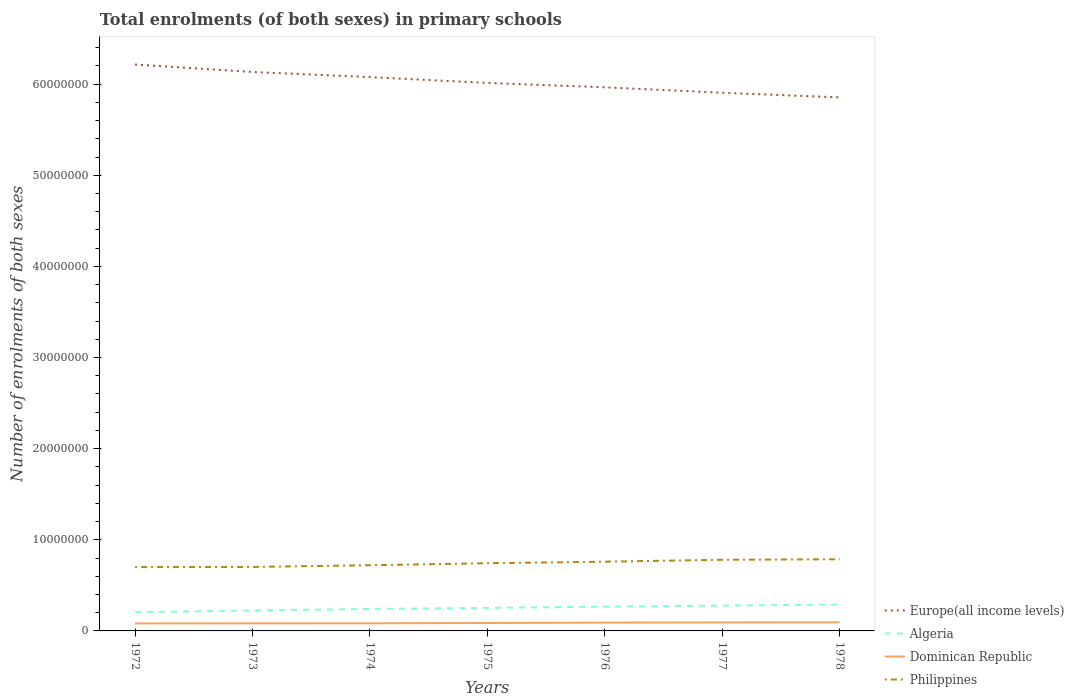Does the line corresponding to Dominican Republic intersect with the line corresponding to Philippines?
Your response must be concise. No. Across all years, what is the maximum number of enrolments in primary schools in Dominican Republic?
Give a very brief answer. 8.24e+05. In which year was the number of enrolments in primary schools in Algeria maximum?
Your answer should be compact. 1972. What is the total number of enrolments in primary schools in Dominican Republic in the graph?
Give a very brief answer. -9.78e+04. What is the difference between the highest and the second highest number of enrolments in primary schools in Algeria?
Make the answer very short. 8.37e+05. Is the number of enrolments in primary schools in Philippines strictly greater than the number of enrolments in primary schools in Dominican Republic over the years?
Make the answer very short. No. How many lines are there?
Provide a succinct answer. 4. How many years are there in the graph?
Offer a terse response. 7. What is the difference between two consecutive major ticks on the Y-axis?
Offer a very short reply. 1.00e+07. Does the graph contain grids?
Your answer should be very brief. No. How many legend labels are there?
Provide a short and direct response. 4. What is the title of the graph?
Your answer should be compact. Total enrolments (of both sexes) in primary schools. What is the label or title of the Y-axis?
Make the answer very short. Number of enrolments of both sexes. What is the Number of enrolments of both sexes of Europe(all income levels) in 1972?
Your answer should be very brief. 6.22e+07. What is the Number of enrolments of both sexes in Algeria in 1972?
Provide a succinct answer. 2.06e+06. What is the Number of enrolments of both sexes of Dominican Republic in 1972?
Make the answer very short. 8.24e+05. What is the Number of enrolments of both sexes of Philippines in 1972?
Ensure brevity in your answer.  7.00e+06. What is the Number of enrolments of both sexes in Europe(all income levels) in 1973?
Provide a succinct answer. 6.13e+07. What is the Number of enrolments of both sexes of Algeria in 1973?
Your answer should be compact. 2.24e+06. What is the Number of enrolments of both sexes in Dominican Republic in 1973?
Make the answer very short. 8.33e+05. What is the Number of enrolments of both sexes in Philippines in 1973?
Keep it short and to the point. 7.02e+06. What is the Number of enrolments of both sexes in Europe(all income levels) in 1974?
Provide a short and direct response. 6.08e+07. What is the Number of enrolments of both sexes in Algeria in 1974?
Provide a succinct answer. 2.41e+06. What is the Number of enrolments of both sexes of Dominican Republic in 1974?
Make the answer very short. 8.37e+05. What is the Number of enrolments of both sexes in Philippines in 1974?
Keep it short and to the point. 7.21e+06. What is the Number of enrolments of both sexes in Europe(all income levels) in 1975?
Your response must be concise. 6.01e+07. What is the Number of enrolments of both sexes in Algeria in 1975?
Provide a succinct answer. 2.53e+06. What is the Number of enrolments of both sexes in Dominican Republic in 1975?
Your response must be concise. 8.68e+05. What is the Number of enrolments of both sexes in Philippines in 1975?
Provide a short and direct response. 7.43e+06. What is the Number of enrolments of both sexes of Europe(all income levels) in 1976?
Your response must be concise. 5.97e+07. What is the Number of enrolments of both sexes of Algeria in 1976?
Your answer should be compact. 2.66e+06. What is the Number of enrolments of both sexes of Dominican Republic in 1976?
Make the answer very short. 9.11e+05. What is the Number of enrolments of both sexes of Philippines in 1976?
Offer a terse response. 7.60e+06. What is the Number of enrolments of both sexes in Europe(all income levels) in 1977?
Ensure brevity in your answer.  5.91e+07. What is the Number of enrolments of both sexes of Algeria in 1977?
Provide a short and direct response. 2.79e+06. What is the Number of enrolments of both sexes in Dominican Republic in 1977?
Keep it short and to the point. 9.35e+05. What is the Number of enrolments of both sexes in Philippines in 1977?
Offer a terse response. 7.81e+06. What is the Number of enrolments of both sexes in Europe(all income levels) in 1978?
Your answer should be very brief. 5.86e+07. What is the Number of enrolments of both sexes of Algeria in 1978?
Offer a terse response. 2.89e+06. What is the Number of enrolments of both sexes in Dominican Republic in 1978?
Make the answer very short. 9.47e+05. What is the Number of enrolments of both sexes of Philippines in 1978?
Offer a terse response. 7.86e+06. Across all years, what is the maximum Number of enrolments of both sexes in Europe(all income levels)?
Ensure brevity in your answer.  6.22e+07. Across all years, what is the maximum Number of enrolments of both sexes of Algeria?
Your answer should be very brief. 2.89e+06. Across all years, what is the maximum Number of enrolments of both sexes in Dominican Republic?
Offer a terse response. 9.47e+05. Across all years, what is the maximum Number of enrolments of both sexes in Philippines?
Provide a short and direct response. 7.86e+06. Across all years, what is the minimum Number of enrolments of both sexes of Europe(all income levels)?
Offer a very short reply. 5.86e+07. Across all years, what is the minimum Number of enrolments of both sexes of Algeria?
Make the answer very short. 2.06e+06. Across all years, what is the minimum Number of enrolments of both sexes in Dominican Republic?
Make the answer very short. 8.24e+05. Across all years, what is the minimum Number of enrolments of both sexes of Philippines?
Keep it short and to the point. 7.00e+06. What is the total Number of enrolments of both sexes in Europe(all income levels) in the graph?
Offer a very short reply. 4.22e+08. What is the total Number of enrolments of both sexes of Algeria in the graph?
Provide a succinct answer. 1.76e+07. What is the total Number of enrolments of both sexes in Dominican Republic in the graph?
Keep it short and to the point. 6.15e+06. What is the total Number of enrolments of both sexes of Philippines in the graph?
Make the answer very short. 5.19e+07. What is the difference between the Number of enrolments of both sexes of Europe(all income levels) in 1972 and that in 1973?
Keep it short and to the point. 8.20e+05. What is the difference between the Number of enrolments of both sexes of Algeria in 1972 and that in 1973?
Give a very brief answer. -1.88e+05. What is the difference between the Number of enrolments of both sexes in Dominican Republic in 1972 and that in 1973?
Make the answer very short. -9886. What is the difference between the Number of enrolments of both sexes of Philippines in 1972 and that in 1973?
Your answer should be very brief. -2.07e+04. What is the difference between the Number of enrolments of both sexes of Europe(all income levels) in 1972 and that in 1974?
Give a very brief answer. 1.38e+06. What is the difference between the Number of enrolments of both sexes of Algeria in 1972 and that in 1974?
Give a very brief answer. -3.52e+05. What is the difference between the Number of enrolments of both sexes of Dominican Republic in 1972 and that in 1974?
Provide a short and direct response. -1.34e+04. What is the difference between the Number of enrolments of both sexes in Philippines in 1972 and that in 1974?
Provide a short and direct response. -2.07e+05. What is the difference between the Number of enrolments of both sexes in Europe(all income levels) in 1972 and that in 1975?
Your answer should be compact. 2.02e+06. What is the difference between the Number of enrolments of both sexes of Algeria in 1972 and that in 1975?
Keep it short and to the point. -4.68e+05. What is the difference between the Number of enrolments of both sexes in Dominican Republic in 1972 and that in 1975?
Your answer should be very brief. -4.40e+04. What is the difference between the Number of enrolments of both sexes of Philippines in 1972 and that in 1975?
Your response must be concise. -4.27e+05. What is the difference between the Number of enrolments of both sexes in Europe(all income levels) in 1972 and that in 1976?
Your answer should be compact. 2.50e+06. What is the difference between the Number of enrolments of both sexes in Algeria in 1972 and that in 1976?
Your answer should be compact. -6.06e+05. What is the difference between the Number of enrolments of both sexes in Dominican Republic in 1972 and that in 1976?
Offer a very short reply. -8.76e+04. What is the difference between the Number of enrolments of both sexes of Philippines in 1972 and that in 1976?
Offer a terse response. -5.95e+05. What is the difference between the Number of enrolments of both sexes of Europe(all income levels) in 1972 and that in 1977?
Your answer should be very brief. 3.10e+06. What is the difference between the Number of enrolments of both sexes of Algeria in 1972 and that in 1977?
Offer a terse response. -7.28e+05. What is the difference between the Number of enrolments of both sexes of Dominican Republic in 1972 and that in 1977?
Your answer should be compact. -1.11e+05. What is the difference between the Number of enrolments of both sexes in Philippines in 1972 and that in 1977?
Make the answer very short. -8.06e+05. What is the difference between the Number of enrolments of both sexes of Europe(all income levels) in 1972 and that in 1978?
Your answer should be compact. 3.61e+06. What is the difference between the Number of enrolments of both sexes of Algeria in 1972 and that in 1978?
Give a very brief answer. -8.37e+05. What is the difference between the Number of enrolments of both sexes of Dominican Republic in 1972 and that in 1978?
Your answer should be compact. -1.23e+05. What is the difference between the Number of enrolments of both sexes of Philippines in 1972 and that in 1978?
Offer a terse response. -8.60e+05. What is the difference between the Number of enrolments of both sexes of Europe(all income levels) in 1973 and that in 1974?
Ensure brevity in your answer.  5.63e+05. What is the difference between the Number of enrolments of both sexes in Algeria in 1973 and that in 1974?
Provide a short and direct response. -1.65e+05. What is the difference between the Number of enrolments of both sexes of Dominican Republic in 1973 and that in 1974?
Offer a terse response. -3503. What is the difference between the Number of enrolments of both sexes in Philippines in 1973 and that in 1974?
Provide a short and direct response. -1.86e+05. What is the difference between the Number of enrolments of both sexes in Europe(all income levels) in 1973 and that in 1975?
Your answer should be very brief. 1.20e+06. What is the difference between the Number of enrolments of both sexes in Algeria in 1973 and that in 1975?
Give a very brief answer. -2.81e+05. What is the difference between the Number of enrolments of both sexes of Dominican Republic in 1973 and that in 1975?
Make the answer very short. -3.42e+04. What is the difference between the Number of enrolments of both sexes of Philippines in 1973 and that in 1975?
Your answer should be very brief. -4.07e+05. What is the difference between the Number of enrolments of both sexes in Europe(all income levels) in 1973 and that in 1976?
Provide a succinct answer. 1.68e+06. What is the difference between the Number of enrolments of both sexes of Algeria in 1973 and that in 1976?
Your response must be concise. -4.18e+05. What is the difference between the Number of enrolments of both sexes of Dominican Republic in 1973 and that in 1976?
Offer a terse response. -7.77e+04. What is the difference between the Number of enrolments of both sexes of Philippines in 1973 and that in 1976?
Your answer should be very brief. -5.75e+05. What is the difference between the Number of enrolments of both sexes of Europe(all income levels) in 1973 and that in 1977?
Offer a very short reply. 2.28e+06. What is the difference between the Number of enrolments of both sexes in Algeria in 1973 and that in 1977?
Your answer should be very brief. -5.40e+05. What is the difference between the Number of enrolments of both sexes in Dominican Republic in 1973 and that in 1977?
Provide a succinct answer. -1.01e+05. What is the difference between the Number of enrolments of both sexes of Philippines in 1973 and that in 1977?
Offer a terse response. -7.85e+05. What is the difference between the Number of enrolments of both sexes in Europe(all income levels) in 1973 and that in 1978?
Your response must be concise. 2.79e+06. What is the difference between the Number of enrolments of both sexes in Algeria in 1973 and that in 1978?
Ensure brevity in your answer.  -6.49e+05. What is the difference between the Number of enrolments of both sexes of Dominican Republic in 1973 and that in 1978?
Make the answer very short. -1.13e+05. What is the difference between the Number of enrolments of both sexes in Philippines in 1973 and that in 1978?
Your answer should be compact. -8.39e+05. What is the difference between the Number of enrolments of both sexes in Europe(all income levels) in 1974 and that in 1975?
Provide a short and direct response. 6.37e+05. What is the difference between the Number of enrolments of both sexes in Algeria in 1974 and that in 1975?
Provide a succinct answer. -1.16e+05. What is the difference between the Number of enrolments of both sexes of Dominican Republic in 1974 and that in 1975?
Your response must be concise. -3.06e+04. What is the difference between the Number of enrolments of both sexes in Philippines in 1974 and that in 1975?
Ensure brevity in your answer.  -2.20e+05. What is the difference between the Number of enrolments of both sexes in Europe(all income levels) in 1974 and that in 1976?
Make the answer very short. 1.12e+06. What is the difference between the Number of enrolments of both sexes of Algeria in 1974 and that in 1976?
Make the answer very short. -2.54e+05. What is the difference between the Number of enrolments of both sexes in Dominican Republic in 1974 and that in 1976?
Provide a succinct answer. -7.42e+04. What is the difference between the Number of enrolments of both sexes of Philippines in 1974 and that in 1976?
Your answer should be compact. -3.88e+05. What is the difference between the Number of enrolments of both sexes in Europe(all income levels) in 1974 and that in 1977?
Your answer should be compact. 1.72e+06. What is the difference between the Number of enrolments of both sexes of Algeria in 1974 and that in 1977?
Provide a short and direct response. -3.76e+05. What is the difference between the Number of enrolments of both sexes in Dominican Republic in 1974 and that in 1977?
Ensure brevity in your answer.  -9.78e+04. What is the difference between the Number of enrolments of both sexes in Philippines in 1974 and that in 1977?
Make the answer very short. -5.99e+05. What is the difference between the Number of enrolments of both sexes of Europe(all income levels) in 1974 and that in 1978?
Your answer should be compact. 2.22e+06. What is the difference between the Number of enrolments of both sexes in Algeria in 1974 and that in 1978?
Your answer should be very brief. -4.85e+05. What is the difference between the Number of enrolments of both sexes in Dominican Republic in 1974 and that in 1978?
Offer a very short reply. -1.10e+05. What is the difference between the Number of enrolments of both sexes in Philippines in 1974 and that in 1978?
Offer a terse response. -6.53e+05. What is the difference between the Number of enrolments of both sexes of Europe(all income levels) in 1975 and that in 1976?
Offer a terse response. 4.81e+05. What is the difference between the Number of enrolments of both sexes in Algeria in 1975 and that in 1976?
Your response must be concise. -1.38e+05. What is the difference between the Number of enrolments of both sexes of Dominican Republic in 1975 and that in 1976?
Ensure brevity in your answer.  -4.36e+04. What is the difference between the Number of enrolments of both sexes in Philippines in 1975 and that in 1976?
Your answer should be very brief. -1.68e+05. What is the difference between the Number of enrolments of both sexes in Europe(all income levels) in 1975 and that in 1977?
Ensure brevity in your answer.  1.08e+06. What is the difference between the Number of enrolments of both sexes in Algeria in 1975 and that in 1977?
Your answer should be compact. -2.60e+05. What is the difference between the Number of enrolments of both sexes in Dominican Republic in 1975 and that in 1977?
Ensure brevity in your answer.  -6.72e+04. What is the difference between the Number of enrolments of both sexes in Philippines in 1975 and that in 1977?
Provide a short and direct response. -3.79e+05. What is the difference between the Number of enrolments of both sexes of Europe(all income levels) in 1975 and that in 1978?
Keep it short and to the point. 1.59e+06. What is the difference between the Number of enrolments of both sexes of Algeria in 1975 and that in 1978?
Keep it short and to the point. -3.69e+05. What is the difference between the Number of enrolments of both sexes of Dominican Republic in 1975 and that in 1978?
Your answer should be compact. -7.93e+04. What is the difference between the Number of enrolments of both sexes in Philippines in 1975 and that in 1978?
Offer a very short reply. -4.32e+05. What is the difference between the Number of enrolments of both sexes in Europe(all income levels) in 1976 and that in 1977?
Your answer should be compact. 5.98e+05. What is the difference between the Number of enrolments of both sexes in Algeria in 1976 and that in 1977?
Ensure brevity in your answer.  -1.22e+05. What is the difference between the Number of enrolments of both sexes in Dominican Republic in 1976 and that in 1977?
Offer a terse response. -2.36e+04. What is the difference between the Number of enrolments of both sexes of Philippines in 1976 and that in 1977?
Offer a terse response. -2.11e+05. What is the difference between the Number of enrolments of both sexes of Europe(all income levels) in 1976 and that in 1978?
Offer a very short reply. 1.11e+06. What is the difference between the Number of enrolments of both sexes of Algeria in 1976 and that in 1978?
Ensure brevity in your answer.  -2.31e+05. What is the difference between the Number of enrolments of both sexes of Dominican Republic in 1976 and that in 1978?
Provide a short and direct response. -3.57e+04. What is the difference between the Number of enrolments of both sexes in Philippines in 1976 and that in 1978?
Give a very brief answer. -2.64e+05. What is the difference between the Number of enrolments of both sexes of Europe(all income levels) in 1977 and that in 1978?
Your response must be concise. 5.08e+05. What is the difference between the Number of enrolments of both sexes of Algeria in 1977 and that in 1978?
Your answer should be very brief. -1.09e+05. What is the difference between the Number of enrolments of both sexes of Dominican Republic in 1977 and that in 1978?
Your response must be concise. -1.21e+04. What is the difference between the Number of enrolments of both sexes in Philippines in 1977 and that in 1978?
Your response must be concise. -5.35e+04. What is the difference between the Number of enrolments of both sexes of Europe(all income levels) in 1972 and the Number of enrolments of both sexes of Algeria in 1973?
Make the answer very short. 5.99e+07. What is the difference between the Number of enrolments of both sexes in Europe(all income levels) in 1972 and the Number of enrolments of both sexes in Dominican Republic in 1973?
Your answer should be very brief. 6.13e+07. What is the difference between the Number of enrolments of both sexes in Europe(all income levels) in 1972 and the Number of enrolments of both sexes in Philippines in 1973?
Your response must be concise. 5.51e+07. What is the difference between the Number of enrolments of both sexes in Algeria in 1972 and the Number of enrolments of both sexes in Dominican Republic in 1973?
Your answer should be compact. 1.22e+06. What is the difference between the Number of enrolments of both sexes of Algeria in 1972 and the Number of enrolments of both sexes of Philippines in 1973?
Your response must be concise. -4.97e+06. What is the difference between the Number of enrolments of both sexes in Dominican Republic in 1972 and the Number of enrolments of both sexes in Philippines in 1973?
Offer a very short reply. -6.20e+06. What is the difference between the Number of enrolments of both sexes of Europe(all income levels) in 1972 and the Number of enrolments of both sexes of Algeria in 1974?
Ensure brevity in your answer.  5.97e+07. What is the difference between the Number of enrolments of both sexes in Europe(all income levels) in 1972 and the Number of enrolments of both sexes in Dominican Republic in 1974?
Keep it short and to the point. 6.13e+07. What is the difference between the Number of enrolments of both sexes of Europe(all income levels) in 1972 and the Number of enrolments of both sexes of Philippines in 1974?
Offer a very short reply. 5.49e+07. What is the difference between the Number of enrolments of both sexes of Algeria in 1972 and the Number of enrolments of both sexes of Dominican Republic in 1974?
Provide a succinct answer. 1.22e+06. What is the difference between the Number of enrolments of both sexes of Algeria in 1972 and the Number of enrolments of both sexes of Philippines in 1974?
Offer a terse response. -5.15e+06. What is the difference between the Number of enrolments of both sexes of Dominican Republic in 1972 and the Number of enrolments of both sexes of Philippines in 1974?
Give a very brief answer. -6.39e+06. What is the difference between the Number of enrolments of both sexes in Europe(all income levels) in 1972 and the Number of enrolments of both sexes in Algeria in 1975?
Provide a short and direct response. 5.96e+07. What is the difference between the Number of enrolments of both sexes of Europe(all income levels) in 1972 and the Number of enrolments of both sexes of Dominican Republic in 1975?
Your response must be concise. 6.13e+07. What is the difference between the Number of enrolments of both sexes in Europe(all income levels) in 1972 and the Number of enrolments of both sexes in Philippines in 1975?
Provide a succinct answer. 5.47e+07. What is the difference between the Number of enrolments of both sexes of Algeria in 1972 and the Number of enrolments of both sexes of Dominican Republic in 1975?
Give a very brief answer. 1.19e+06. What is the difference between the Number of enrolments of both sexes in Algeria in 1972 and the Number of enrolments of both sexes in Philippines in 1975?
Ensure brevity in your answer.  -5.37e+06. What is the difference between the Number of enrolments of both sexes in Dominican Republic in 1972 and the Number of enrolments of both sexes in Philippines in 1975?
Ensure brevity in your answer.  -6.61e+06. What is the difference between the Number of enrolments of both sexes in Europe(all income levels) in 1972 and the Number of enrolments of both sexes in Algeria in 1976?
Give a very brief answer. 5.95e+07. What is the difference between the Number of enrolments of both sexes of Europe(all income levels) in 1972 and the Number of enrolments of both sexes of Dominican Republic in 1976?
Offer a very short reply. 6.12e+07. What is the difference between the Number of enrolments of both sexes of Europe(all income levels) in 1972 and the Number of enrolments of both sexes of Philippines in 1976?
Your answer should be compact. 5.46e+07. What is the difference between the Number of enrolments of both sexes in Algeria in 1972 and the Number of enrolments of both sexes in Dominican Republic in 1976?
Provide a succinct answer. 1.15e+06. What is the difference between the Number of enrolments of both sexes in Algeria in 1972 and the Number of enrolments of both sexes in Philippines in 1976?
Offer a very short reply. -5.54e+06. What is the difference between the Number of enrolments of both sexes in Dominican Republic in 1972 and the Number of enrolments of both sexes in Philippines in 1976?
Make the answer very short. -6.77e+06. What is the difference between the Number of enrolments of both sexes in Europe(all income levels) in 1972 and the Number of enrolments of both sexes in Algeria in 1977?
Provide a succinct answer. 5.94e+07. What is the difference between the Number of enrolments of both sexes in Europe(all income levels) in 1972 and the Number of enrolments of both sexes in Dominican Republic in 1977?
Your answer should be very brief. 6.12e+07. What is the difference between the Number of enrolments of both sexes in Europe(all income levels) in 1972 and the Number of enrolments of both sexes in Philippines in 1977?
Your answer should be very brief. 5.43e+07. What is the difference between the Number of enrolments of both sexes in Algeria in 1972 and the Number of enrolments of both sexes in Dominican Republic in 1977?
Your response must be concise. 1.12e+06. What is the difference between the Number of enrolments of both sexes of Algeria in 1972 and the Number of enrolments of both sexes of Philippines in 1977?
Offer a very short reply. -5.75e+06. What is the difference between the Number of enrolments of both sexes of Dominican Republic in 1972 and the Number of enrolments of both sexes of Philippines in 1977?
Keep it short and to the point. -6.98e+06. What is the difference between the Number of enrolments of both sexes in Europe(all income levels) in 1972 and the Number of enrolments of both sexes in Algeria in 1978?
Keep it short and to the point. 5.93e+07. What is the difference between the Number of enrolments of both sexes in Europe(all income levels) in 1972 and the Number of enrolments of both sexes in Dominican Republic in 1978?
Provide a short and direct response. 6.12e+07. What is the difference between the Number of enrolments of both sexes of Europe(all income levels) in 1972 and the Number of enrolments of both sexes of Philippines in 1978?
Offer a terse response. 5.43e+07. What is the difference between the Number of enrolments of both sexes of Algeria in 1972 and the Number of enrolments of both sexes of Dominican Republic in 1978?
Your response must be concise. 1.11e+06. What is the difference between the Number of enrolments of both sexes of Algeria in 1972 and the Number of enrolments of both sexes of Philippines in 1978?
Your answer should be compact. -5.80e+06. What is the difference between the Number of enrolments of both sexes of Dominican Republic in 1972 and the Number of enrolments of both sexes of Philippines in 1978?
Make the answer very short. -7.04e+06. What is the difference between the Number of enrolments of both sexes of Europe(all income levels) in 1973 and the Number of enrolments of both sexes of Algeria in 1974?
Offer a terse response. 5.89e+07. What is the difference between the Number of enrolments of both sexes of Europe(all income levels) in 1973 and the Number of enrolments of both sexes of Dominican Republic in 1974?
Your response must be concise. 6.05e+07. What is the difference between the Number of enrolments of both sexes in Europe(all income levels) in 1973 and the Number of enrolments of both sexes in Philippines in 1974?
Give a very brief answer. 5.41e+07. What is the difference between the Number of enrolments of both sexes of Algeria in 1973 and the Number of enrolments of both sexes of Dominican Republic in 1974?
Provide a succinct answer. 1.41e+06. What is the difference between the Number of enrolments of both sexes of Algeria in 1973 and the Number of enrolments of both sexes of Philippines in 1974?
Give a very brief answer. -4.96e+06. What is the difference between the Number of enrolments of both sexes in Dominican Republic in 1973 and the Number of enrolments of both sexes in Philippines in 1974?
Make the answer very short. -6.38e+06. What is the difference between the Number of enrolments of both sexes in Europe(all income levels) in 1973 and the Number of enrolments of both sexes in Algeria in 1975?
Offer a terse response. 5.88e+07. What is the difference between the Number of enrolments of both sexes of Europe(all income levels) in 1973 and the Number of enrolments of both sexes of Dominican Republic in 1975?
Provide a short and direct response. 6.05e+07. What is the difference between the Number of enrolments of both sexes of Europe(all income levels) in 1973 and the Number of enrolments of both sexes of Philippines in 1975?
Keep it short and to the point. 5.39e+07. What is the difference between the Number of enrolments of both sexes in Algeria in 1973 and the Number of enrolments of both sexes in Dominican Republic in 1975?
Ensure brevity in your answer.  1.38e+06. What is the difference between the Number of enrolments of both sexes of Algeria in 1973 and the Number of enrolments of both sexes of Philippines in 1975?
Provide a short and direct response. -5.18e+06. What is the difference between the Number of enrolments of both sexes of Dominican Republic in 1973 and the Number of enrolments of both sexes of Philippines in 1975?
Offer a terse response. -6.60e+06. What is the difference between the Number of enrolments of both sexes in Europe(all income levels) in 1973 and the Number of enrolments of both sexes in Algeria in 1976?
Offer a very short reply. 5.87e+07. What is the difference between the Number of enrolments of both sexes of Europe(all income levels) in 1973 and the Number of enrolments of both sexes of Dominican Republic in 1976?
Your answer should be compact. 6.04e+07. What is the difference between the Number of enrolments of both sexes in Europe(all income levels) in 1973 and the Number of enrolments of both sexes in Philippines in 1976?
Provide a short and direct response. 5.37e+07. What is the difference between the Number of enrolments of both sexes in Algeria in 1973 and the Number of enrolments of both sexes in Dominican Republic in 1976?
Provide a short and direct response. 1.33e+06. What is the difference between the Number of enrolments of both sexes of Algeria in 1973 and the Number of enrolments of both sexes of Philippines in 1976?
Ensure brevity in your answer.  -5.35e+06. What is the difference between the Number of enrolments of both sexes in Dominican Republic in 1973 and the Number of enrolments of both sexes in Philippines in 1976?
Provide a short and direct response. -6.76e+06. What is the difference between the Number of enrolments of both sexes in Europe(all income levels) in 1973 and the Number of enrolments of both sexes in Algeria in 1977?
Offer a terse response. 5.86e+07. What is the difference between the Number of enrolments of both sexes of Europe(all income levels) in 1973 and the Number of enrolments of both sexes of Dominican Republic in 1977?
Offer a very short reply. 6.04e+07. What is the difference between the Number of enrolments of both sexes in Europe(all income levels) in 1973 and the Number of enrolments of both sexes in Philippines in 1977?
Your response must be concise. 5.35e+07. What is the difference between the Number of enrolments of both sexes in Algeria in 1973 and the Number of enrolments of both sexes in Dominican Republic in 1977?
Make the answer very short. 1.31e+06. What is the difference between the Number of enrolments of both sexes of Algeria in 1973 and the Number of enrolments of both sexes of Philippines in 1977?
Your response must be concise. -5.56e+06. What is the difference between the Number of enrolments of both sexes of Dominican Republic in 1973 and the Number of enrolments of both sexes of Philippines in 1977?
Provide a short and direct response. -6.97e+06. What is the difference between the Number of enrolments of both sexes of Europe(all income levels) in 1973 and the Number of enrolments of both sexes of Algeria in 1978?
Provide a succinct answer. 5.84e+07. What is the difference between the Number of enrolments of both sexes of Europe(all income levels) in 1973 and the Number of enrolments of both sexes of Dominican Republic in 1978?
Your response must be concise. 6.04e+07. What is the difference between the Number of enrolments of both sexes of Europe(all income levels) in 1973 and the Number of enrolments of both sexes of Philippines in 1978?
Provide a succinct answer. 5.35e+07. What is the difference between the Number of enrolments of both sexes of Algeria in 1973 and the Number of enrolments of both sexes of Dominican Republic in 1978?
Provide a short and direct response. 1.30e+06. What is the difference between the Number of enrolments of both sexes in Algeria in 1973 and the Number of enrolments of both sexes in Philippines in 1978?
Provide a succinct answer. -5.62e+06. What is the difference between the Number of enrolments of both sexes in Dominican Republic in 1973 and the Number of enrolments of both sexes in Philippines in 1978?
Your answer should be very brief. -7.03e+06. What is the difference between the Number of enrolments of both sexes in Europe(all income levels) in 1974 and the Number of enrolments of both sexes in Algeria in 1975?
Offer a terse response. 5.82e+07. What is the difference between the Number of enrolments of both sexes of Europe(all income levels) in 1974 and the Number of enrolments of both sexes of Dominican Republic in 1975?
Your answer should be compact. 5.99e+07. What is the difference between the Number of enrolments of both sexes in Europe(all income levels) in 1974 and the Number of enrolments of both sexes in Philippines in 1975?
Offer a very short reply. 5.33e+07. What is the difference between the Number of enrolments of both sexes of Algeria in 1974 and the Number of enrolments of both sexes of Dominican Republic in 1975?
Provide a short and direct response. 1.54e+06. What is the difference between the Number of enrolments of both sexes in Algeria in 1974 and the Number of enrolments of both sexes in Philippines in 1975?
Give a very brief answer. -5.02e+06. What is the difference between the Number of enrolments of both sexes of Dominican Republic in 1974 and the Number of enrolments of both sexes of Philippines in 1975?
Your answer should be compact. -6.59e+06. What is the difference between the Number of enrolments of both sexes in Europe(all income levels) in 1974 and the Number of enrolments of both sexes in Algeria in 1976?
Offer a very short reply. 5.81e+07. What is the difference between the Number of enrolments of both sexes in Europe(all income levels) in 1974 and the Number of enrolments of both sexes in Dominican Republic in 1976?
Your answer should be very brief. 5.99e+07. What is the difference between the Number of enrolments of both sexes of Europe(all income levels) in 1974 and the Number of enrolments of both sexes of Philippines in 1976?
Offer a terse response. 5.32e+07. What is the difference between the Number of enrolments of both sexes in Algeria in 1974 and the Number of enrolments of both sexes in Dominican Republic in 1976?
Make the answer very short. 1.50e+06. What is the difference between the Number of enrolments of both sexes in Algeria in 1974 and the Number of enrolments of both sexes in Philippines in 1976?
Your response must be concise. -5.19e+06. What is the difference between the Number of enrolments of both sexes in Dominican Republic in 1974 and the Number of enrolments of both sexes in Philippines in 1976?
Give a very brief answer. -6.76e+06. What is the difference between the Number of enrolments of both sexes of Europe(all income levels) in 1974 and the Number of enrolments of both sexes of Algeria in 1977?
Give a very brief answer. 5.80e+07. What is the difference between the Number of enrolments of both sexes in Europe(all income levels) in 1974 and the Number of enrolments of both sexes in Dominican Republic in 1977?
Offer a very short reply. 5.98e+07. What is the difference between the Number of enrolments of both sexes of Europe(all income levels) in 1974 and the Number of enrolments of both sexes of Philippines in 1977?
Offer a very short reply. 5.30e+07. What is the difference between the Number of enrolments of both sexes in Algeria in 1974 and the Number of enrolments of both sexes in Dominican Republic in 1977?
Make the answer very short. 1.47e+06. What is the difference between the Number of enrolments of both sexes of Algeria in 1974 and the Number of enrolments of both sexes of Philippines in 1977?
Ensure brevity in your answer.  -5.40e+06. What is the difference between the Number of enrolments of both sexes in Dominican Republic in 1974 and the Number of enrolments of both sexes in Philippines in 1977?
Offer a terse response. -6.97e+06. What is the difference between the Number of enrolments of both sexes in Europe(all income levels) in 1974 and the Number of enrolments of both sexes in Algeria in 1978?
Your answer should be compact. 5.79e+07. What is the difference between the Number of enrolments of both sexes of Europe(all income levels) in 1974 and the Number of enrolments of both sexes of Dominican Republic in 1978?
Provide a short and direct response. 5.98e+07. What is the difference between the Number of enrolments of both sexes of Europe(all income levels) in 1974 and the Number of enrolments of both sexes of Philippines in 1978?
Provide a succinct answer. 5.29e+07. What is the difference between the Number of enrolments of both sexes in Algeria in 1974 and the Number of enrolments of both sexes in Dominican Republic in 1978?
Make the answer very short. 1.46e+06. What is the difference between the Number of enrolments of both sexes of Algeria in 1974 and the Number of enrolments of both sexes of Philippines in 1978?
Your answer should be compact. -5.45e+06. What is the difference between the Number of enrolments of both sexes in Dominican Republic in 1974 and the Number of enrolments of both sexes in Philippines in 1978?
Ensure brevity in your answer.  -7.02e+06. What is the difference between the Number of enrolments of both sexes of Europe(all income levels) in 1975 and the Number of enrolments of both sexes of Algeria in 1976?
Your answer should be very brief. 5.75e+07. What is the difference between the Number of enrolments of both sexes in Europe(all income levels) in 1975 and the Number of enrolments of both sexes in Dominican Republic in 1976?
Give a very brief answer. 5.92e+07. What is the difference between the Number of enrolments of both sexes of Europe(all income levels) in 1975 and the Number of enrolments of both sexes of Philippines in 1976?
Provide a succinct answer. 5.25e+07. What is the difference between the Number of enrolments of both sexes in Algeria in 1975 and the Number of enrolments of both sexes in Dominican Republic in 1976?
Your response must be concise. 1.61e+06. What is the difference between the Number of enrolments of both sexes of Algeria in 1975 and the Number of enrolments of both sexes of Philippines in 1976?
Your answer should be very brief. -5.07e+06. What is the difference between the Number of enrolments of both sexes of Dominican Republic in 1975 and the Number of enrolments of both sexes of Philippines in 1976?
Give a very brief answer. -6.73e+06. What is the difference between the Number of enrolments of both sexes in Europe(all income levels) in 1975 and the Number of enrolments of both sexes in Algeria in 1977?
Your response must be concise. 5.74e+07. What is the difference between the Number of enrolments of both sexes in Europe(all income levels) in 1975 and the Number of enrolments of both sexes in Dominican Republic in 1977?
Offer a terse response. 5.92e+07. What is the difference between the Number of enrolments of both sexes of Europe(all income levels) in 1975 and the Number of enrolments of both sexes of Philippines in 1977?
Offer a terse response. 5.23e+07. What is the difference between the Number of enrolments of both sexes of Algeria in 1975 and the Number of enrolments of both sexes of Dominican Republic in 1977?
Offer a terse response. 1.59e+06. What is the difference between the Number of enrolments of both sexes in Algeria in 1975 and the Number of enrolments of both sexes in Philippines in 1977?
Your answer should be very brief. -5.28e+06. What is the difference between the Number of enrolments of both sexes of Dominican Republic in 1975 and the Number of enrolments of both sexes of Philippines in 1977?
Offer a very short reply. -6.94e+06. What is the difference between the Number of enrolments of both sexes in Europe(all income levels) in 1975 and the Number of enrolments of both sexes in Algeria in 1978?
Keep it short and to the point. 5.72e+07. What is the difference between the Number of enrolments of both sexes of Europe(all income levels) in 1975 and the Number of enrolments of both sexes of Dominican Republic in 1978?
Make the answer very short. 5.92e+07. What is the difference between the Number of enrolments of both sexes in Europe(all income levels) in 1975 and the Number of enrolments of both sexes in Philippines in 1978?
Provide a succinct answer. 5.23e+07. What is the difference between the Number of enrolments of both sexes of Algeria in 1975 and the Number of enrolments of both sexes of Dominican Republic in 1978?
Your response must be concise. 1.58e+06. What is the difference between the Number of enrolments of both sexes of Algeria in 1975 and the Number of enrolments of both sexes of Philippines in 1978?
Provide a succinct answer. -5.34e+06. What is the difference between the Number of enrolments of both sexes of Dominican Republic in 1975 and the Number of enrolments of both sexes of Philippines in 1978?
Your answer should be very brief. -6.99e+06. What is the difference between the Number of enrolments of both sexes in Europe(all income levels) in 1976 and the Number of enrolments of both sexes in Algeria in 1977?
Offer a terse response. 5.69e+07. What is the difference between the Number of enrolments of both sexes in Europe(all income levels) in 1976 and the Number of enrolments of both sexes in Dominican Republic in 1977?
Your answer should be very brief. 5.87e+07. What is the difference between the Number of enrolments of both sexes in Europe(all income levels) in 1976 and the Number of enrolments of both sexes in Philippines in 1977?
Ensure brevity in your answer.  5.18e+07. What is the difference between the Number of enrolments of both sexes in Algeria in 1976 and the Number of enrolments of both sexes in Dominican Republic in 1977?
Provide a succinct answer. 1.73e+06. What is the difference between the Number of enrolments of both sexes in Algeria in 1976 and the Number of enrolments of both sexes in Philippines in 1977?
Provide a succinct answer. -5.14e+06. What is the difference between the Number of enrolments of both sexes of Dominican Republic in 1976 and the Number of enrolments of both sexes of Philippines in 1977?
Your answer should be very brief. -6.90e+06. What is the difference between the Number of enrolments of both sexes of Europe(all income levels) in 1976 and the Number of enrolments of both sexes of Algeria in 1978?
Your response must be concise. 5.68e+07. What is the difference between the Number of enrolments of both sexes of Europe(all income levels) in 1976 and the Number of enrolments of both sexes of Dominican Republic in 1978?
Give a very brief answer. 5.87e+07. What is the difference between the Number of enrolments of both sexes in Europe(all income levels) in 1976 and the Number of enrolments of both sexes in Philippines in 1978?
Provide a succinct answer. 5.18e+07. What is the difference between the Number of enrolments of both sexes of Algeria in 1976 and the Number of enrolments of both sexes of Dominican Republic in 1978?
Keep it short and to the point. 1.72e+06. What is the difference between the Number of enrolments of both sexes in Algeria in 1976 and the Number of enrolments of both sexes in Philippines in 1978?
Give a very brief answer. -5.20e+06. What is the difference between the Number of enrolments of both sexes of Dominican Republic in 1976 and the Number of enrolments of both sexes of Philippines in 1978?
Offer a terse response. -6.95e+06. What is the difference between the Number of enrolments of both sexes in Europe(all income levels) in 1977 and the Number of enrolments of both sexes in Algeria in 1978?
Make the answer very short. 5.62e+07. What is the difference between the Number of enrolments of both sexes of Europe(all income levels) in 1977 and the Number of enrolments of both sexes of Dominican Republic in 1978?
Offer a terse response. 5.81e+07. What is the difference between the Number of enrolments of both sexes of Europe(all income levels) in 1977 and the Number of enrolments of both sexes of Philippines in 1978?
Offer a very short reply. 5.12e+07. What is the difference between the Number of enrolments of both sexes of Algeria in 1977 and the Number of enrolments of both sexes of Dominican Republic in 1978?
Your answer should be compact. 1.84e+06. What is the difference between the Number of enrolments of both sexes in Algeria in 1977 and the Number of enrolments of both sexes in Philippines in 1978?
Make the answer very short. -5.08e+06. What is the difference between the Number of enrolments of both sexes in Dominican Republic in 1977 and the Number of enrolments of both sexes in Philippines in 1978?
Your answer should be compact. -6.93e+06. What is the average Number of enrolments of both sexes of Europe(all income levels) per year?
Keep it short and to the point. 6.02e+07. What is the average Number of enrolments of both sexes of Algeria per year?
Make the answer very short. 2.51e+06. What is the average Number of enrolments of both sexes of Dominican Republic per year?
Give a very brief answer. 8.79e+05. What is the average Number of enrolments of both sexes of Philippines per year?
Keep it short and to the point. 7.42e+06. In the year 1972, what is the difference between the Number of enrolments of both sexes in Europe(all income levels) and Number of enrolments of both sexes in Algeria?
Offer a terse response. 6.01e+07. In the year 1972, what is the difference between the Number of enrolments of both sexes of Europe(all income levels) and Number of enrolments of both sexes of Dominican Republic?
Provide a short and direct response. 6.13e+07. In the year 1972, what is the difference between the Number of enrolments of both sexes of Europe(all income levels) and Number of enrolments of both sexes of Philippines?
Provide a succinct answer. 5.52e+07. In the year 1972, what is the difference between the Number of enrolments of both sexes of Algeria and Number of enrolments of both sexes of Dominican Republic?
Your answer should be very brief. 1.23e+06. In the year 1972, what is the difference between the Number of enrolments of both sexes of Algeria and Number of enrolments of both sexes of Philippines?
Your answer should be very brief. -4.94e+06. In the year 1972, what is the difference between the Number of enrolments of both sexes of Dominican Republic and Number of enrolments of both sexes of Philippines?
Your answer should be very brief. -6.18e+06. In the year 1973, what is the difference between the Number of enrolments of both sexes in Europe(all income levels) and Number of enrolments of both sexes in Algeria?
Ensure brevity in your answer.  5.91e+07. In the year 1973, what is the difference between the Number of enrolments of both sexes of Europe(all income levels) and Number of enrolments of both sexes of Dominican Republic?
Make the answer very short. 6.05e+07. In the year 1973, what is the difference between the Number of enrolments of both sexes of Europe(all income levels) and Number of enrolments of both sexes of Philippines?
Provide a short and direct response. 5.43e+07. In the year 1973, what is the difference between the Number of enrolments of both sexes in Algeria and Number of enrolments of both sexes in Dominican Republic?
Keep it short and to the point. 1.41e+06. In the year 1973, what is the difference between the Number of enrolments of both sexes in Algeria and Number of enrolments of both sexes in Philippines?
Your response must be concise. -4.78e+06. In the year 1973, what is the difference between the Number of enrolments of both sexes of Dominican Republic and Number of enrolments of both sexes of Philippines?
Your answer should be very brief. -6.19e+06. In the year 1974, what is the difference between the Number of enrolments of both sexes in Europe(all income levels) and Number of enrolments of both sexes in Algeria?
Offer a terse response. 5.84e+07. In the year 1974, what is the difference between the Number of enrolments of both sexes of Europe(all income levels) and Number of enrolments of both sexes of Dominican Republic?
Ensure brevity in your answer.  5.99e+07. In the year 1974, what is the difference between the Number of enrolments of both sexes in Europe(all income levels) and Number of enrolments of both sexes in Philippines?
Provide a succinct answer. 5.36e+07. In the year 1974, what is the difference between the Number of enrolments of both sexes of Algeria and Number of enrolments of both sexes of Dominican Republic?
Provide a succinct answer. 1.57e+06. In the year 1974, what is the difference between the Number of enrolments of both sexes of Algeria and Number of enrolments of both sexes of Philippines?
Your response must be concise. -4.80e+06. In the year 1974, what is the difference between the Number of enrolments of both sexes of Dominican Republic and Number of enrolments of both sexes of Philippines?
Keep it short and to the point. -6.37e+06. In the year 1975, what is the difference between the Number of enrolments of both sexes in Europe(all income levels) and Number of enrolments of both sexes in Algeria?
Provide a succinct answer. 5.76e+07. In the year 1975, what is the difference between the Number of enrolments of both sexes in Europe(all income levels) and Number of enrolments of both sexes in Dominican Republic?
Offer a terse response. 5.93e+07. In the year 1975, what is the difference between the Number of enrolments of both sexes in Europe(all income levels) and Number of enrolments of both sexes in Philippines?
Provide a short and direct response. 5.27e+07. In the year 1975, what is the difference between the Number of enrolments of both sexes in Algeria and Number of enrolments of both sexes in Dominican Republic?
Provide a short and direct response. 1.66e+06. In the year 1975, what is the difference between the Number of enrolments of both sexes of Algeria and Number of enrolments of both sexes of Philippines?
Your answer should be very brief. -4.90e+06. In the year 1975, what is the difference between the Number of enrolments of both sexes in Dominican Republic and Number of enrolments of both sexes in Philippines?
Give a very brief answer. -6.56e+06. In the year 1976, what is the difference between the Number of enrolments of both sexes of Europe(all income levels) and Number of enrolments of both sexes of Algeria?
Your answer should be compact. 5.70e+07. In the year 1976, what is the difference between the Number of enrolments of both sexes in Europe(all income levels) and Number of enrolments of both sexes in Dominican Republic?
Offer a very short reply. 5.87e+07. In the year 1976, what is the difference between the Number of enrolments of both sexes of Europe(all income levels) and Number of enrolments of both sexes of Philippines?
Offer a terse response. 5.21e+07. In the year 1976, what is the difference between the Number of enrolments of both sexes in Algeria and Number of enrolments of both sexes in Dominican Republic?
Offer a terse response. 1.75e+06. In the year 1976, what is the difference between the Number of enrolments of both sexes of Algeria and Number of enrolments of both sexes of Philippines?
Your response must be concise. -4.93e+06. In the year 1976, what is the difference between the Number of enrolments of both sexes in Dominican Republic and Number of enrolments of both sexes in Philippines?
Keep it short and to the point. -6.69e+06. In the year 1977, what is the difference between the Number of enrolments of both sexes in Europe(all income levels) and Number of enrolments of both sexes in Algeria?
Provide a short and direct response. 5.63e+07. In the year 1977, what is the difference between the Number of enrolments of both sexes in Europe(all income levels) and Number of enrolments of both sexes in Dominican Republic?
Ensure brevity in your answer.  5.81e+07. In the year 1977, what is the difference between the Number of enrolments of both sexes of Europe(all income levels) and Number of enrolments of both sexes of Philippines?
Provide a succinct answer. 5.12e+07. In the year 1977, what is the difference between the Number of enrolments of both sexes of Algeria and Number of enrolments of both sexes of Dominican Republic?
Your response must be concise. 1.85e+06. In the year 1977, what is the difference between the Number of enrolments of both sexes of Algeria and Number of enrolments of both sexes of Philippines?
Offer a terse response. -5.02e+06. In the year 1977, what is the difference between the Number of enrolments of both sexes of Dominican Republic and Number of enrolments of both sexes of Philippines?
Your response must be concise. -6.87e+06. In the year 1978, what is the difference between the Number of enrolments of both sexes in Europe(all income levels) and Number of enrolments of both sexes in Algeria?
Make the answer very short. 5.57e+07. In the year 1978, what is the difference between the Number of enrolments of both sexes in Europe(all income levels) and Number of enrolments of both sexes in Dominican Republic?
Ensure brevity in your answer.  5.76e+07. In the year 1978, what is the difference between the Number of enrolments of both sexes in Europe(all income levels) and Number of enrolments of both sexes in Philippines?
Provide a succinct answer. 5.07e+07. In the year 1978, what is the difference between the Number of enrolments of both sexes in Algeria and Number of enrolments of both sexes in Dominican Republic?
Keep it short and to the point. 1.95e+06. In the year 1978, what is the difference between the Number of enrolments of both sexes of Algeria and Number of enrolments of both sexes of Philippines?
Offer a very short reply. -4.97e+06. In the year 1978, what is the difference between the Number of enrolments of both sexes of Dominican Republic and Number of enrolments of both sexes of Philippines?
Make the answer very short. -6.91e+06. What is the ratio of the Number of enrolments of both sexes of Europe(all income levels) in 1972 to that in 1973?
Your answer should be very brief. 1.01. What is the ratio of the Number of enrolments of both sexes in Algeria in 1972 to that in 1973?
Your response must be concise. 0.92. What is the ratio of the Number of enrolments of both sexes in Philippines in 1972 to that in 1973?
Ensure brevity in your answer.  1. What is the ratio of the Number of enrolments of both sexes in Europe(all income levels) in 1972 to that in 1974?
Make the answer very short. 1.02. What is the ratio of the Number of enrolments of both sexes of Algeria in 1972 to that in 1974?
Give a very brief answer. 0.85. What is the ratio of the Number of enrolments of both sexes of Dominican Republic in 1972 to that in 1974?
Offer a very short reply. 0.98. What is the ratio of the Number of enrolments of both sexes of Philippines in 1972 to that in 1974?
Your response must be concise. 0.97. What is the ratio of the Number of enrolments of both sexes of Europe(all income levels) in 1972 to that in 1975?
Offer a very short reply. 1.03. What is the ratio of the Number of enrolments of both sexes in Algeria in 1972 to that in 1975?
Offer a terse response. 0.81. What is the ratio of the Number of enrolments of both sexes in Dominican Republic in 1972 to that in 1975?
Provide a succinct answer. 0.95. What is the ratio of the Number of enrolments of both sexes in Philippines in 1972 to that in 1975?
Give a very brief answer. 0.94. What is the ratio of the Number of enrolments of both sexes in Europe(all income levels) in 1972 to that in 1976?
Ensure brevity in your answer.  1.04. What is the ratio of the Number of enrolments of both sexes of Algeria in 1972 to that in 1976?
Make the answer very short. 0.77. What is the ratio of the Number of enrolments of both sexes of Dominican Republic in 1972 to that in 1976?
Offer a very short reply. 0.9. What is the ratio of the Number of enrolments of both sexes of Philippines in 1972 to that in 1976?
Ensure brevity in your answer.  0.92. What is the ratio of the Number of enrolments of both sexes in Europe(all income levels) in 1972 to that in 1977?
Provide a succinct answer. 1.05. What is the ratio of the Number of enrolments of both sexes of Algeria in 1972 to that in 1977?
Your answer should be very brief. 0.74. What is the ratio of the Number of enrolments of both sexes of Dominican Republic in 1972 to that in 1977?
Your response must be concise. 0.88. What is the ratio of the Number of enrolments of both sexes of Philippines in 1972 to that in 1977?
Provide a short and direct response. 0.9. What is the ratio of the Number of enrolments of both sexes in Europe(all income levels) in 1972 to that in 1978?
Ensure brevity in your answer.  1.06. What is the ratio of the Number of enrolments of both sexes of Algeria in 1972 to that in 1978?
Offer a very short reply. 0.71. What is the ratio of the Number of enrolments of both sexes of Dominican Republic in 1972 to that in 1978?
Offer a very short reply. 0.87. What is the ratio of the Number of enrolments of both sexes in Philippines in 1972 to that in 1978?
Ensure brevity in your answer.  0.89. What is the ratio of the Number of enrolments of both sexes in Europe(all income levels) in 1973 to that in 1974?
Your answer should be very brief. 1.01. What is the ratio of the Number of enrolments of both sexes of Algeria in 1973 to that in 1974?
Your answer should be very brief. 0.93. What is the ratio of the Number of enrolments of both sexes of Philippines in 1973 to that in 1974?
Give a very brief answer. 0.97. What is the ratio of the Number of enrolments of both sexes in Algeria in 1973 to that in 1975?
Keep it short and to the point. 0.89. What is the ratio of the Number of enrolments of both sexes in Dominican Republic in 1973 to that in 1975?
Give a very brief answer. 0.96. What is the ratio of the Number of enrolments of both sexes in Philippines in 1973 to that in 1975?
Make the answer very short. 0.95. What is the ratio of the Number of enrolments of both sexes in Europe(all income levels) in 1973 to that in 1976?
Give a very brief answer. 1.03. What is the ratio of the Number of enrolments of both sexes of Algeria in 1973 to that in 1976?
Provide a succinct answer. 0.84. What is the ratio of the Number of enrolments of both sexes in Dominican Republic in 1973 to that in 1976?
Your response must be concise. 0.91. What is the ratio of the Number of enrolments of both sexes in Philippines in 1973 to that in 1976?
Provide a short and direct response. 0.92. What is the ratio of the Number of enrolments of both sexes in Europe(all income levels) in 1973 to that in 1977?
Provide a short and direct response. 1.04. What is the ratio of the Number of enrolments of both sexes in Algeria in 1973 to that in 1977?
Make the answer very short. 0.81. What is the ratio of the Number of enrolments of both sexes in Dominican Republic in 1973 to that in 1977?
Your response must be concise. 0.89. What is the ratio of the Number of enrolments of both sexes in Philippines in 1973 to that in 1977?
Offer a very short reply. 0.9. What is the ratio of the Number of enrolments of both sexes of Europe(all income levels) in 1973 to that in 1978?
Keep it short and to the point. 1.05. What is the ratio of the Number of enrolments of both sexes in Algeria in 1973 to that in 1978?
Offer a very short reply. 0.78. What is the ratio of the Number of enrolments of both sexes in Dominican Republic in 1973 to that in 1978?
Provide a succinct answer. 0.88. What is the ratio of the Number of enrolments of both sexes in Philippines in 1973 to that in 1978?
Offer a terse response. 0.89. What is the ratio of the Number of enrolments of both sexes in Europe(all income levels) in 1974 to that in 1975?
Your answer should be very brief. 1.01. What is the ratio of the Number of enrolments of both sexes in Algeria in 1974 to that in 1975?
Your response must be concise. 0.95. What is the ratio of the Number of enrolments of both sexes in Dominican Republic in 1974 to that in 1975?
Your answer should be very brief. 0.96. What is the ratio of the Number of enrolments of both sexes in Philippines in 1974 to that in 1975?
Make the answer very short. 0.97. What is the ratio of the Number of enrolments of both sexes of Europe(all income levels) in 1974 to that in 1976?
Make the answer very short. 1.02. What is the ratio of the Number of enrolments of both sexes in Algeria in 1974 to that in 1976?
Keep it short and to the point. 0.9. What is the ratio of the Number of enrolments of both sexes of Dominican Republic in 1974 to that in 1976?
Make the answer very short. 0.92. What is the ratio of the Number of enrolments of both sexes of Philippines in 1974 to that in 1976?
Ensure brevity in your answer.  0.95. What is the ratio of the Number of enrolments of both sexes in Europe(all income levels) in 1974 to that in 1977?
Ensure brevity in your answer.  1.03. What is the ratio of the Number of enrolments of both sexes of Algeria in 1974 to that in 1977?
Provide a short and direct response. 0.86. What is the ratio of the Number of enrolments of both sexes in Dominican Republic in 1974 to that in 1977?
Offer a very short reply. 0.9. What is the ratio of the Number of enrolments of both sexes of Philippines in 1974 to that in 1977?
Provide a succinct answer. 0.92. What is the ratio of the Number of enrolments of both sexes in Europe(all income levels) in 1974 to that in 1978?
Give a very brief answer. 1.04. What is the ratio of the Number of enrolments of both sexes of Algeria in 1974 to that in 1978?
Offer a terse response. 0.83. What is the ratio of the Number of enrolments of both sexes in Dominican Republic in 1974 to that in 1978?
Make the answer very short. 0.88. What is the ratio of the Number of enrolments of both sexes of Philippines in 1974 to that in 1978?
Offer a very short reply. 0.92. What is the ratio of the Number of enrolments of both sexes of Algeria in 1975 to that in 1976?
Give a very brief answer. 0.95. What is the ratio of the Number of enrolments of both sexes in Dominican Republic in 1975 to that in 1976?
Offer a very short reply. 0.95. What is the ratio of the Number of enrolments of both sexes in Philippines in 1975 to that in 1976?
Your response must be concise. 0.98. What is the ratio of the Number of enrolments of both sexes of Europe(all income levels) in 1975 to that in 1977?
Your response must be concise. 1.02. What is the ratio of the Number of enrolments of both sexes in Algeria in 1975 to that in 1977?
Provide a short and direct response. 0.91. What is the ratio of the Number of enrolments of both sexes in Dominican Republic in 1975 to that in 1977?
Give a very brief answer. 0.93. What is the ratio of the Number of enrolments of both sexes of Philippines in 1975 to that in 1977?
Offer a terse response. 0.95. What is the ratio of the Number of enrolments of both sexes in Europe(all income levels) in 1975 to that in 1978?
Give a very brief answer. 1.03. What is the ratio of the Number of enrolments of both sexes of Algeria in 1975 to that in 1978?
Your answer should be compact. 0.87. What is the ratio of the Number of enrolments of both sexes in Dominican Republic in 1975 to that in 1978?
Keep it short and to the point. 0.92. What is the ratio of the Number of enrolments of both sexes of Philippines in 1975 to that in 1978?
Provide a short and direct response. 0.94. What is the ratio of the Number of enrolments of both sexes of Europe(all income levels) in 1976 to that in 1977?
Make the answer very short. 1.01. What is the ratio of the Number of enrolments of both sexes in Algeria in 1976 to that in 1977?
Provide a short and direct response. 0.96. What is the ratio of the Number of enrolments of both sexes of Dominican Republic in 1976 to that in 1977?
Provide a short and direct response. 0.97. What is the ratio of the Number of enrolments of both sexes of Europe(all income levels) in 1976 to that in 1978?
Offer a very short reply. 1.02. What is the ratio of the Number of enrolments of both sexes of Algeria in 1976 to that in 1978?
Keep it short and to the point. 0.92. What is the ratio of the Number of enrolments of both sexes in Dominican Republic in 1976 to that in 1978?
Your answer should be compact. 0.96. What is the ratio of the Number of enrolments of both sexes of Philippines in 1976 to that in 1978?
Keep it short and to the point. 0.97. What is the ratio of the Number of enrolments of both sexes in Europe(all income levels) in 1977 to that in 1978?
Provide a succinct answer. 1.01. What is the ratio of the Number of enrolments of both sexes of Algeria in 1977 to that in 1978?
Your response must be concise. 0.96. What is the ratio of the Number of enrolments of both sexes in Dominican Republic in 1977 to that in 1978?
Your response must be concise. 0.99. What is the difference between the highest and the second highest Number of enrolments of both sexes of Europe(all income levels)?
Offer a terse response. 8.20e+05. What is the difference between the highest and the second highest Number of enrolments of both sexes of Algeria?
Keep it short and to the point. 1.09e+05. What is the difference between the highest and the second highest Number of enrolments of both sexes in Dominican Republic?
Your answer should be compact. 1.21e+04. What is the difference between the highest and the second highest Number of enrolments of both sexes in Philippines?
Your answer should be compact. 5.35e+04. What is the difference between the highest and the lowest Number of enrolments of both sexes in Europe(all income levels)?
Give a very brief answer. 3.61e+06. What is the difference between the highest and the lowest Number of enrolments of both sexes of Algeria?
Keep it short and to the point. 8.37e+05. What is the difference between the highest and the lowest Number of enrolments of both sexes in Dominican Republic?
Provide a short and direct response. 1.23e+05. What is the difference between the highest and the lowest Number of enrolments of both sexes in Philippines?
Provide a short and direct response. 8.60e+05. 